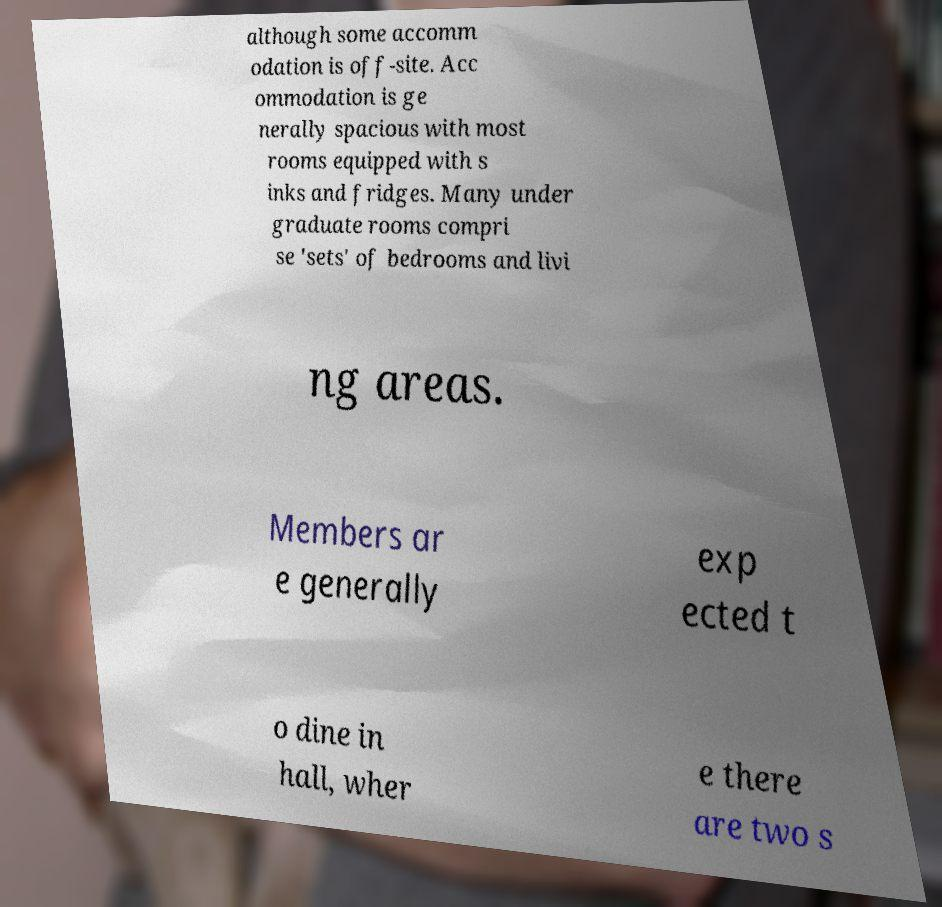What messages or text are displayed in this image? I need them in a readable, typed format. although some accomm odation is off-site. Acc ommodation is ge nerally spacious with most rooms equipped with s inks and fridges. Many under graduate rooms compri se 'sets' of bedrooms and livi ng areas. Members ar e generally exp ected t o dine in hall, wher e there are two s 